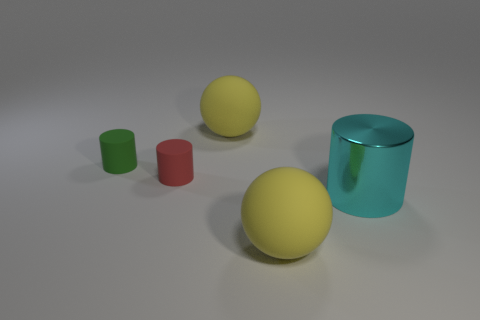What size is the thing that is in front of the small red cylinder and to the left of the cyan shiny cylinder? large 